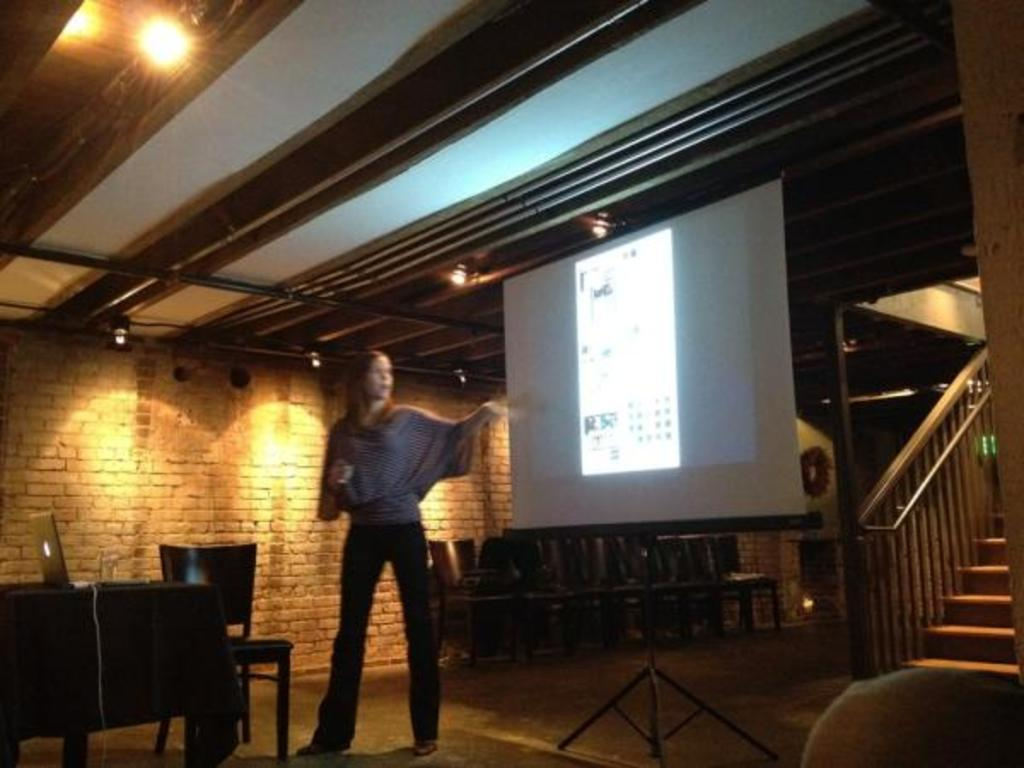What is attached to the roof in the image? Lights are attached to the roof. What can be seen on the wall in the image? There is a screen in the image. What type of furniture is present in the image? There are chairs in the image. What electronic device is on the table in the image? A laptop is present on a table. Who is in the image? A woman is standing in the image. What architectural feature is visible in the image? There are steps in the image. Can you see any steam coming from the cup in the image? There is no cup present in the image, so it is not possible to see any steam. 